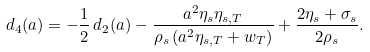<formula> <loc_0><loc_0><loc_500><loc_500>d _ { 4 } ( a ) = - \frac { 1 } { 2 } \, d _ { 2 } ( a ) - \frac { a ^ { 2 } \eta _ { s } \eta _ { s , T } } { \rho _ { s } \left ( a ^ { 2 } \eta _ { s , T } + w _ { T } \right ) } + \frac { 2 \eta _ { s } + \sigma _ { s } } { 2 \rho _ { s } } .</formula> 